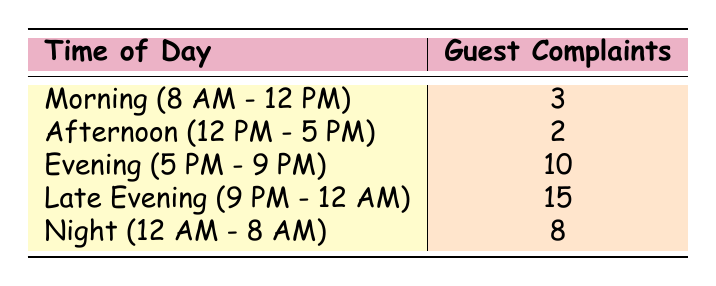What is the total number of guest complaints during the Late Evening? The Late Evening has a specific row in the table that indicates the number of guest complaints, which is 15. No calculations are necessary since the value is directly available.
Answer: 15 Which time of day had the least guest complaints? Looking through the table, the Afternoon (12 PM - 5 PM) row shows the lowest number of complaints, which is 2. This week is compared against all other time slots to find the minimum value.
Answer: 2 What is the average number of guest complaints for the Morning and Night? First, we find the values for Morning (3 complaints) and Night (8 complaints), then sum these (3 + 8 = 11), and divide by the number of periods (2) to get the average: 11/2 = 5.5.
Answer: 5.5 Is it true that the number of complaints during the Evening is greater than during the Afternoon? The number of complaints in the Evening is 10, while in the Afternoon it is 2. Since 10 is greater than 2, the statement is true.
Answer: Yes How many more complaints were there in the Late Evening compared to the Evening? The Late Evening has 15 complaints and the Evening has 10 complaints. We subtract the number of Evening complaints from those in Late Evening (15 - 10 = 5) to find the difference.
Answer: 5 What is the total number of guest complaints recorded in the table? To calculate the total, sum all the complaints: 3 (Morning) + 2 (Afternoon) + 10 (Evening) + 15 (Late Evening) + 8 (Night) = 38. This total is derived by adding up each category individually.
Answer: 38 Are there more complaints during the Night than in the Morning? The Night has 8 complaints while the Morning has 3 complaints. Since 8 is greater than 3, the answer is yes.
Answer: Yes Which time slot had the highest guest complaints? By reviewing the numbers, we see that the Late Evening, with 15 complaints, is higher than any other time of day listed in the table. No calculations are required, just a comparison of all values to find the maximum.
Answer: Late Evening If we combine the complaints from Morning and Afternoon, how does that compare to the total from Night? The total for Morning and Afternoon is 3 + 2 = 5. The Night has 8 complaints, and if we compare 5 (from Morning and Afternoon) with 8 (from Night), 8 is greater.
Answer: Night is greater 